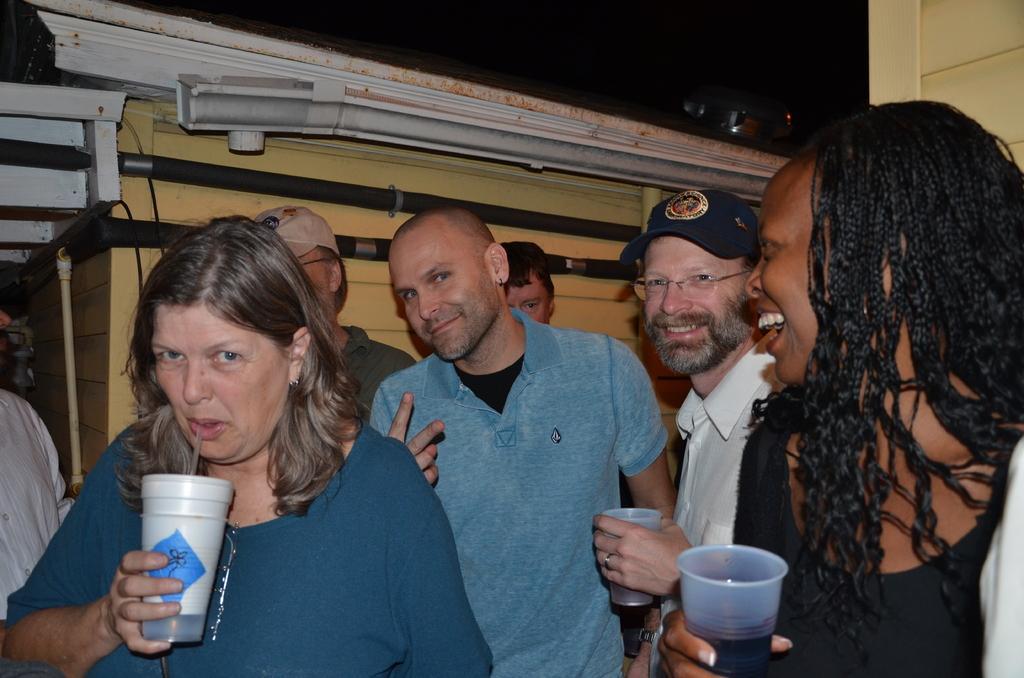How would you summarize this image in a sentence or two? In the picture we can see this woman wearing a dress is holding a tin in her hands and these two persons on the right side are also holding a glass with a drink in it. In the background, we can see a few more people, we can see the wall and pipes. 